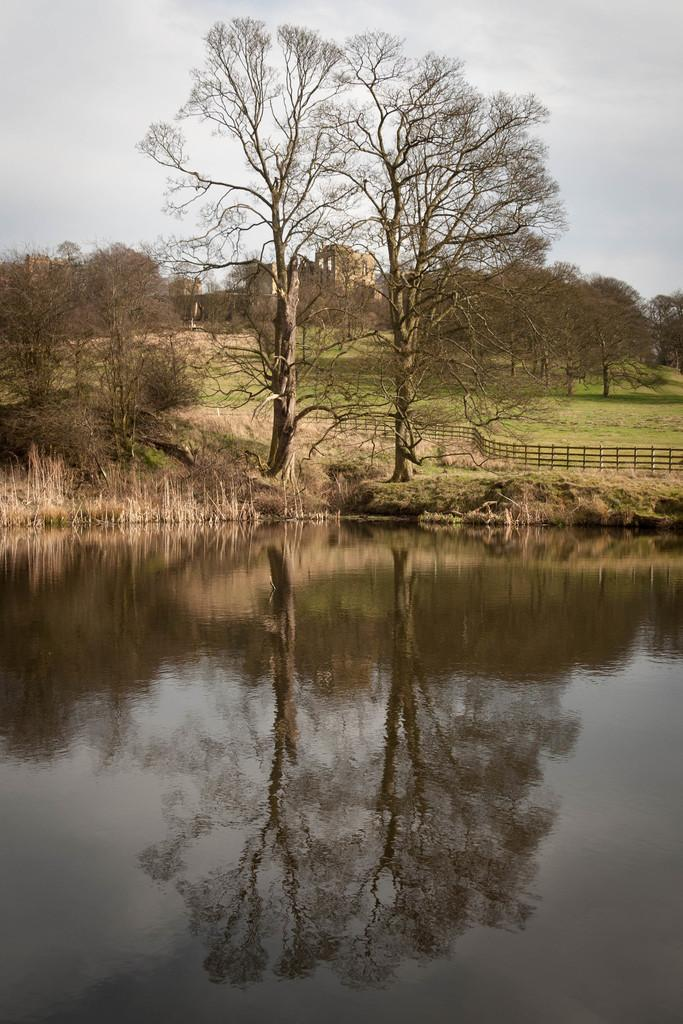What type of vegetation can be seen in the image? There are many trees, plants, and grass visible in the image. What is the material of the fencing on the right side of the image? The fencing on the right side of the image is made of wood. What can be seen at the bottom of the image? There is water visible at the bottom of the image. What is visible at the top of the image? The sky is visible at the top of the image, and clouds are present in the sky. What is the title of the cookbook being used in the image? There is no cookbook present in the image. What type of government is depicted in the image? There is no depiction of a government in the image. 